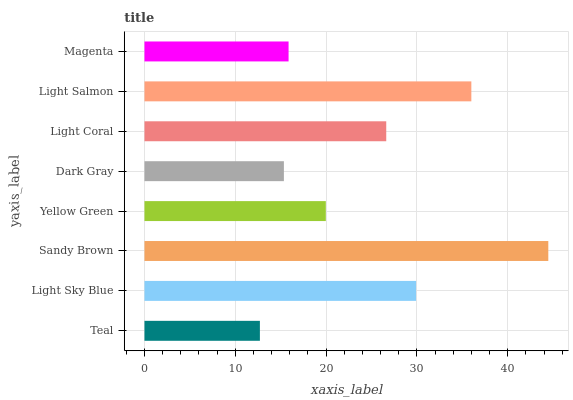Is Teal the minimum?
Answer yes or no. Yes. Is Sandy Brown the maximum?
Answer yes or no. Yes. Is Light Sky Blue the minimum?
Answer yes or no. No. Is Light Sky Blue the maximum?
Answer yes or no. No. Is Light Sky Blue greater than Teal?
Answer yes or no. Yes. Is Teal less than Light Sky Blue?
Answer yes or no. Yes. Is Teal greater than Light Sky Blue?
Answer yes or no. No. Is Light Sky Blue less than Teal?
Answer yes or no. No. Is Light Coral the high median?
Answer yes or no. Yes. Is Yellow Green the low median?
Answer yes or no. Yes. Is Light Salmon the high median?
Answer yes or no. No. Is Sandy Brown the low median?
Answer yes or no. No. 